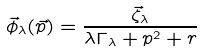Convert formula to latex. <formula><loc_0><loc_0><loc_500><loc_500>\vec { \phi } _ { \lambda } ( \vec { p } ) = \frac { \vec { \zeta } _ { \lambda } } { \lambda \Gamma _ { \lambda } + p ^ { 2 } + r }</formula> 